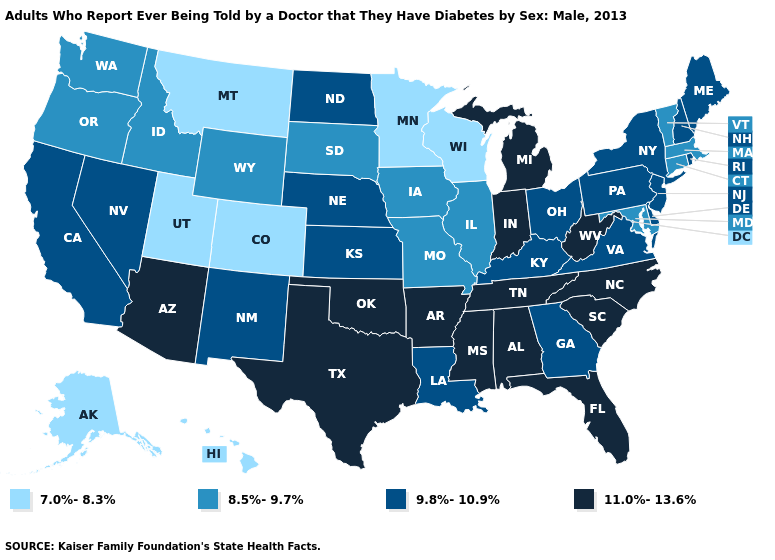What is the lowest value in the West?
Give a very brief answer. 7.0%-8.3%. How many symbols are there in the legend?
Short answer required. 4. Which states have the highest value in the USA?
Be succinct. Alabama, Arizona, Arkansas, Florida, Indiana, Michigan, Mississippi, North Carolina, Oklahoma, South Carolina, Tennessee, Texas, West Virginia. Does the first symbol in the legend represent the smallest category?
Write a very short answer. Yes. What is the value of Missouri?
Write a very short answer. 8.5%-9.7%. Which states have the lowest value in the USA?
Give a very brief answer. Alaska, Colorado, Hawaii, Minnesota, Montana, Utah, Wisconsin. What is the lowest value in the Northeast?
Short answer required. 8.5%-9.7%. Is the legend a continuous bar?
Quick response, please. No. What is the value of New Mexico?
Answer briefly. 9.8%-10.9%. What is the value of Michigan?
Answer briefly. 11.0%-13.6%. Does Nebraska have a lower value than California?
Quick response, please. No. Among the states that border Alabama , does Georgia have the highest value?
Short answer required. No. What is the value of Ohio?
Answer briefly. 9.8%-10.9%. 